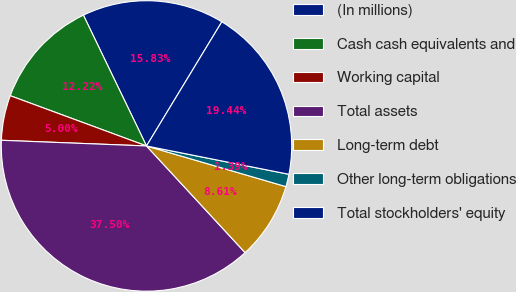Convert chart to OTSL. <chart><loc_0><loc_0><loc_500><loc_500><pie_chart><fcel>(In millions)<fcel>Cash cash equivalents and<fcel>Working capital<fcel>Total assets<fcel>Long-term debt<fcel>Other long-term obligations<fcel>Total stockholders' equity<nl><fcel>15.83%<fcel>12.22%<fcel>5.0%<fcel>37.49%<fcel>8.61%<fcel>1.39%<fcel>19.44%<nl></chart> 